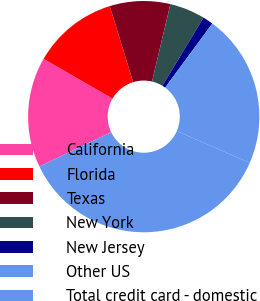<chart> <loc_0><loc_0><loc_500><loc_500><pie_chart><fcel>California<fcel>Florida<fcel>Texas<fcel>New York<fcel>New Jersey<fcel>Other US<fcel>Total credit card - domestic<nl><fcel>15.42%<fcel>11.93%<fcel>8.44%<fcel>4.95%<fcel>1.46%<fcel>21.43%<fcel>36.38%<nl></chart> 